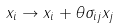<formula> <loc_0><loc_0><loc_500><loc_500>x _ { i } \to x _ { i } + \theta \sigma _ { i j } x _ { j }</formula> 